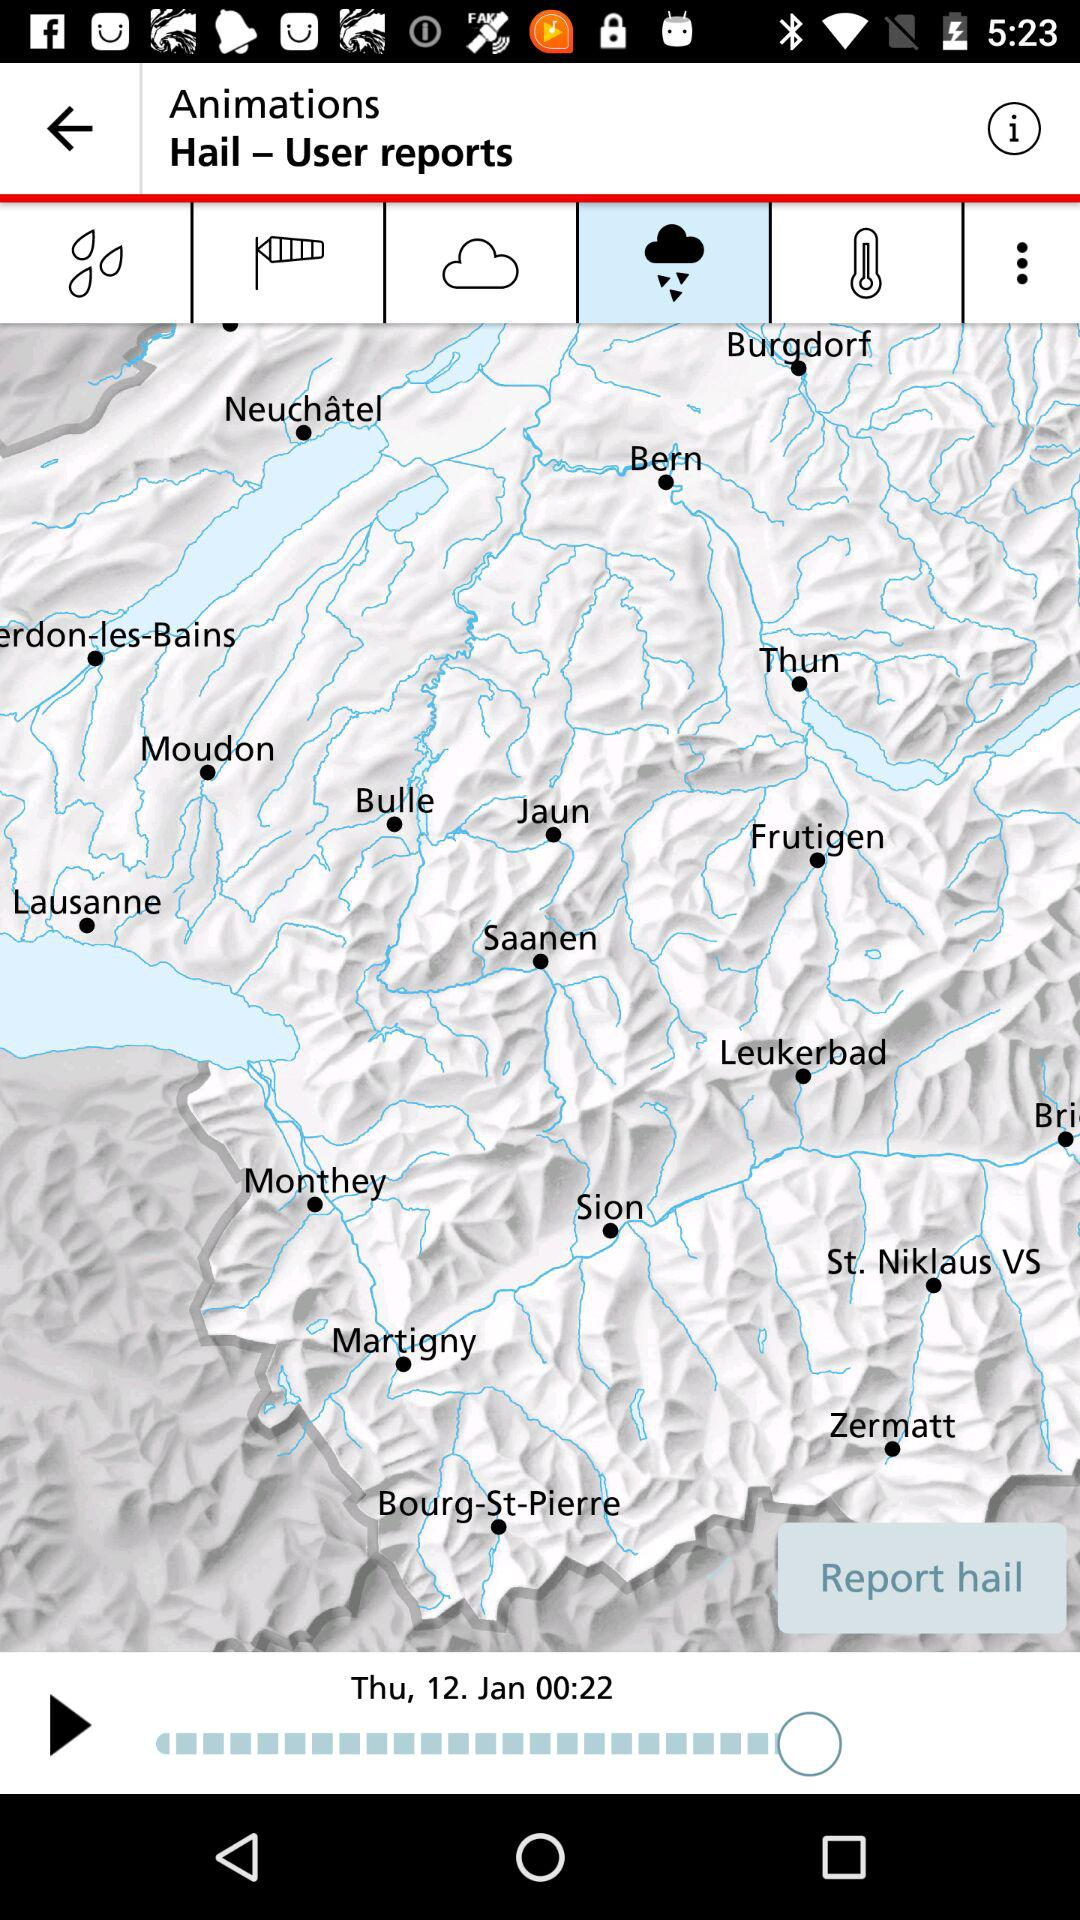What's the date? The date is Thursday, January 12. 